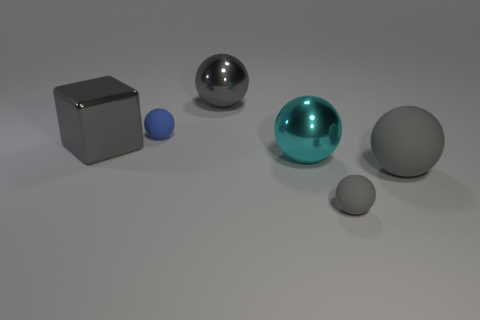The big matte sphere is what color?
Provide a succinct answer. Gray. There is a metallic ball that is behind the cyan shiny object; is its size the same as the small gray rubber sphere?
Provide a succinct answer. No. What is the gray sphere behind the cyan object right of the large gray sphere that is to the left of the large cyan metal object made of?
Offer a terse response. Metal. There is a rubber sphere behind the large gray rubber ball; does it have the same color as the ball that is to the right of the tiny gray object?
Your response must be concise. No. What material is the gray sphere in front of the large gray sphere that is to the right of the small gray matte object?
Give a very brief answer. Rubber. What color is the other matte ball that is the same size as the blue ball?
Your answer should be compact. Gray. Does the cyan metal object have the same shape as the gray metallic object to the right of the blue sphere?
Your answer should be very brief. Yes. There is a large metal sphere that is to the right of the big gray ball left of the cyan sphere; how many rubber things are in front of it?
Ensure brevity in your answer.  2. There is a gray object that is on the left side of the rubber sphere that is on the left side of the cyan sphere; what is its size?
Your answer should be compact. Large. The other sphere that is the same material as the large cyan sphere is what size?
Make the answer very short. Large. 